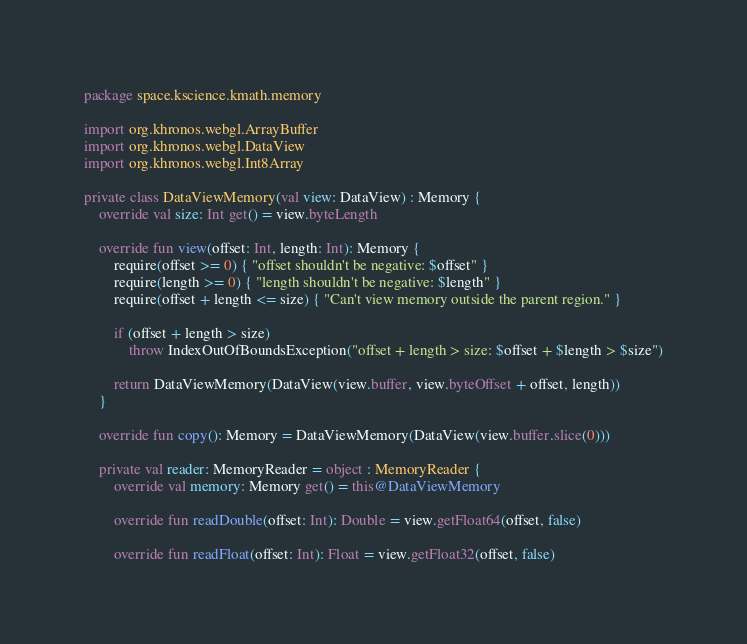<code> <loc_0><loc_0><loc_500><loc_500><_Kotlin_>package space.kscience.kmath.memory

import org.khronos.webgl.ArrayBuffer
import org.khronos.webgl.DataView
import org.khronos.webgl.Int8Array

private class DataViewMemory(val view: DataView) : Memory {
    override val size: Int get() = view.byteLength

    override fun view(offset: Int, length: Int): Memory {
        require(offset >= 0) { "offset shouldn't be negative: $offset" }
        require(length >= 0) { "length shouldn't be negative: $length" }
        require(offset + length <= size) { "Can't view memory outside the parent region." }

        if (offset + length > size)
            throw IndexOutOfBoundsException("offset + length > size: $offset + $length > $size")

        return DataViewMemory(DataView(view.buffer, view.byteOffset + offset, length))
    }

    override fun copy(): Memory = DataViewMemory(DataView(view.buffer.slice(0)))

    private val reader: MemoryReader = object : MemoryReader {
        override val memory: Memory get() = this@DataViewMemory

        override fun readDouble(offset: Int): Double = view.getFloat64(offset, false)

        override fun readFloat(offset: Int): Float = view.getFloat32(offset, false)
</code> 